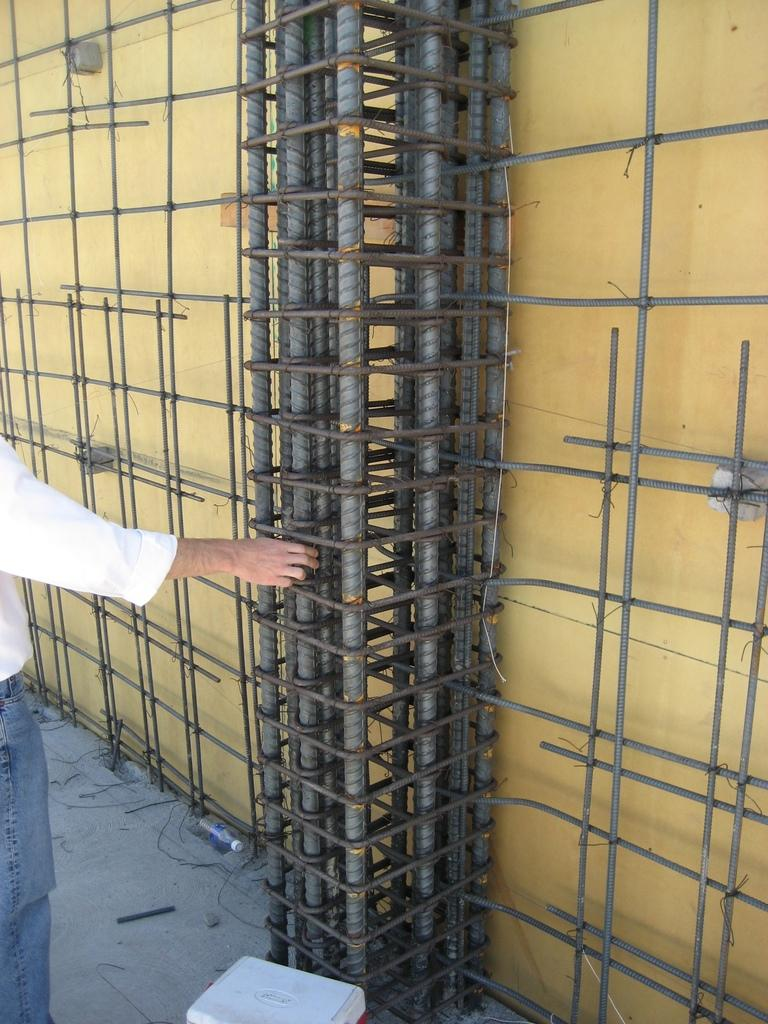What color is the wall in the image? There is a yellow wall in the image. What can be seen beside the yellow wall? There are iron roads beside the yellow wall. Can you describe the person on the left side of the image? The person is wearing a white shirt and holding a rod. What other objects are present in the image? There is a bottle and a box in the image. What direction is the person arguing with the stocking in the image? There is no person arguing with a stocking in the image. The person is simply standing on the left side of the image, wearing a white shirt and holding a rod. 